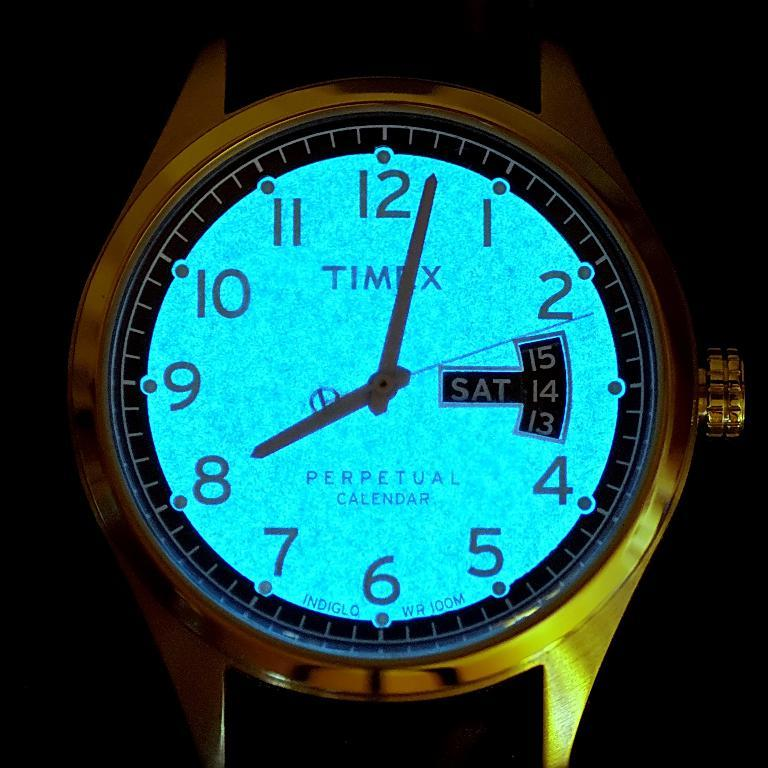Provide a one-sentence caption for the provided image. Glowing watch that has the word TIMEX on the face. 